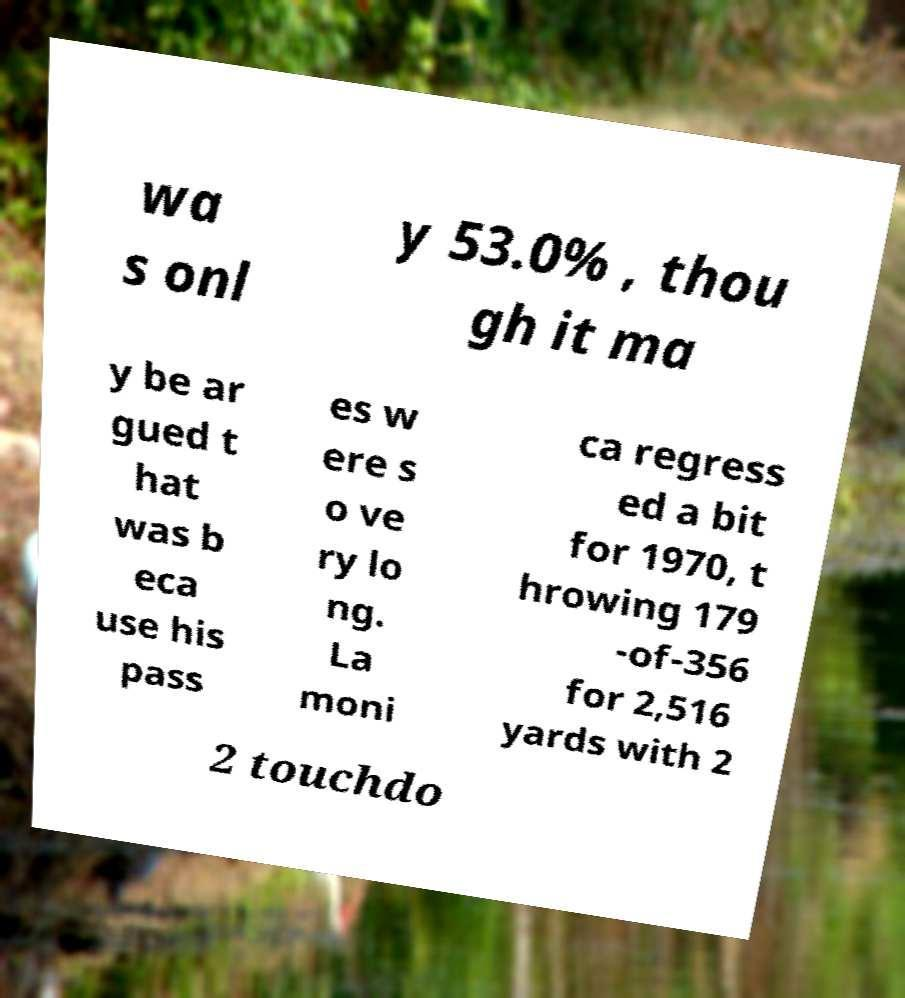What messages or text are displayed in this image? I need them in a readable, typed format. wa s onl y 53.0% , thou gh it ma y be ar gued t hat was b eca use his pass es w ere s o ve ry lo ng. La moni ca regress ed a bit for 1970, t hrowing 179 -of-356 for 2,516 yards with 2 2 touchdo 